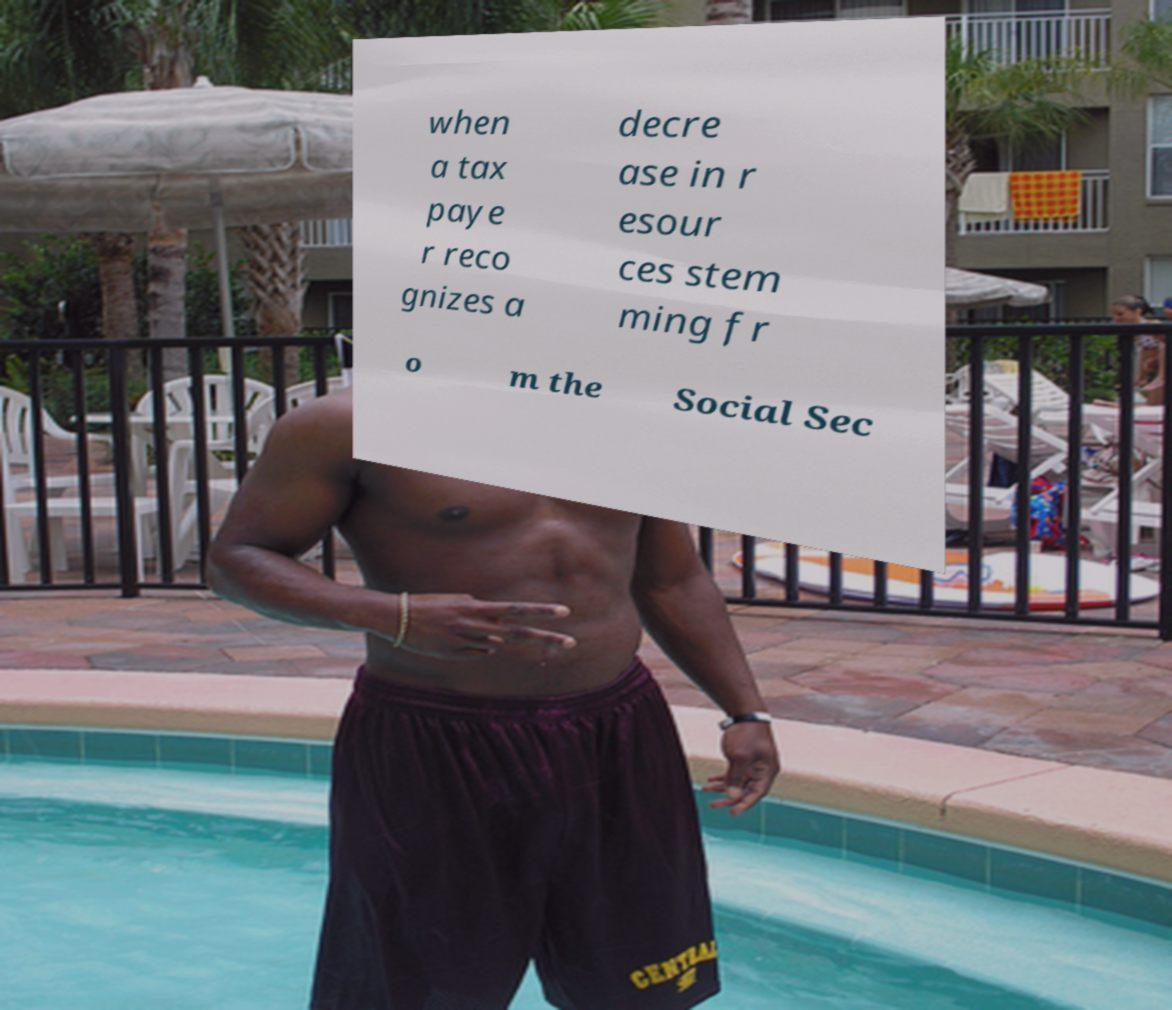Can you accurately transcribe the text from the provided image for me? when a tax paye r reco gnizes a decre ase in r esour ces stem ming fr o m the Social Sec 